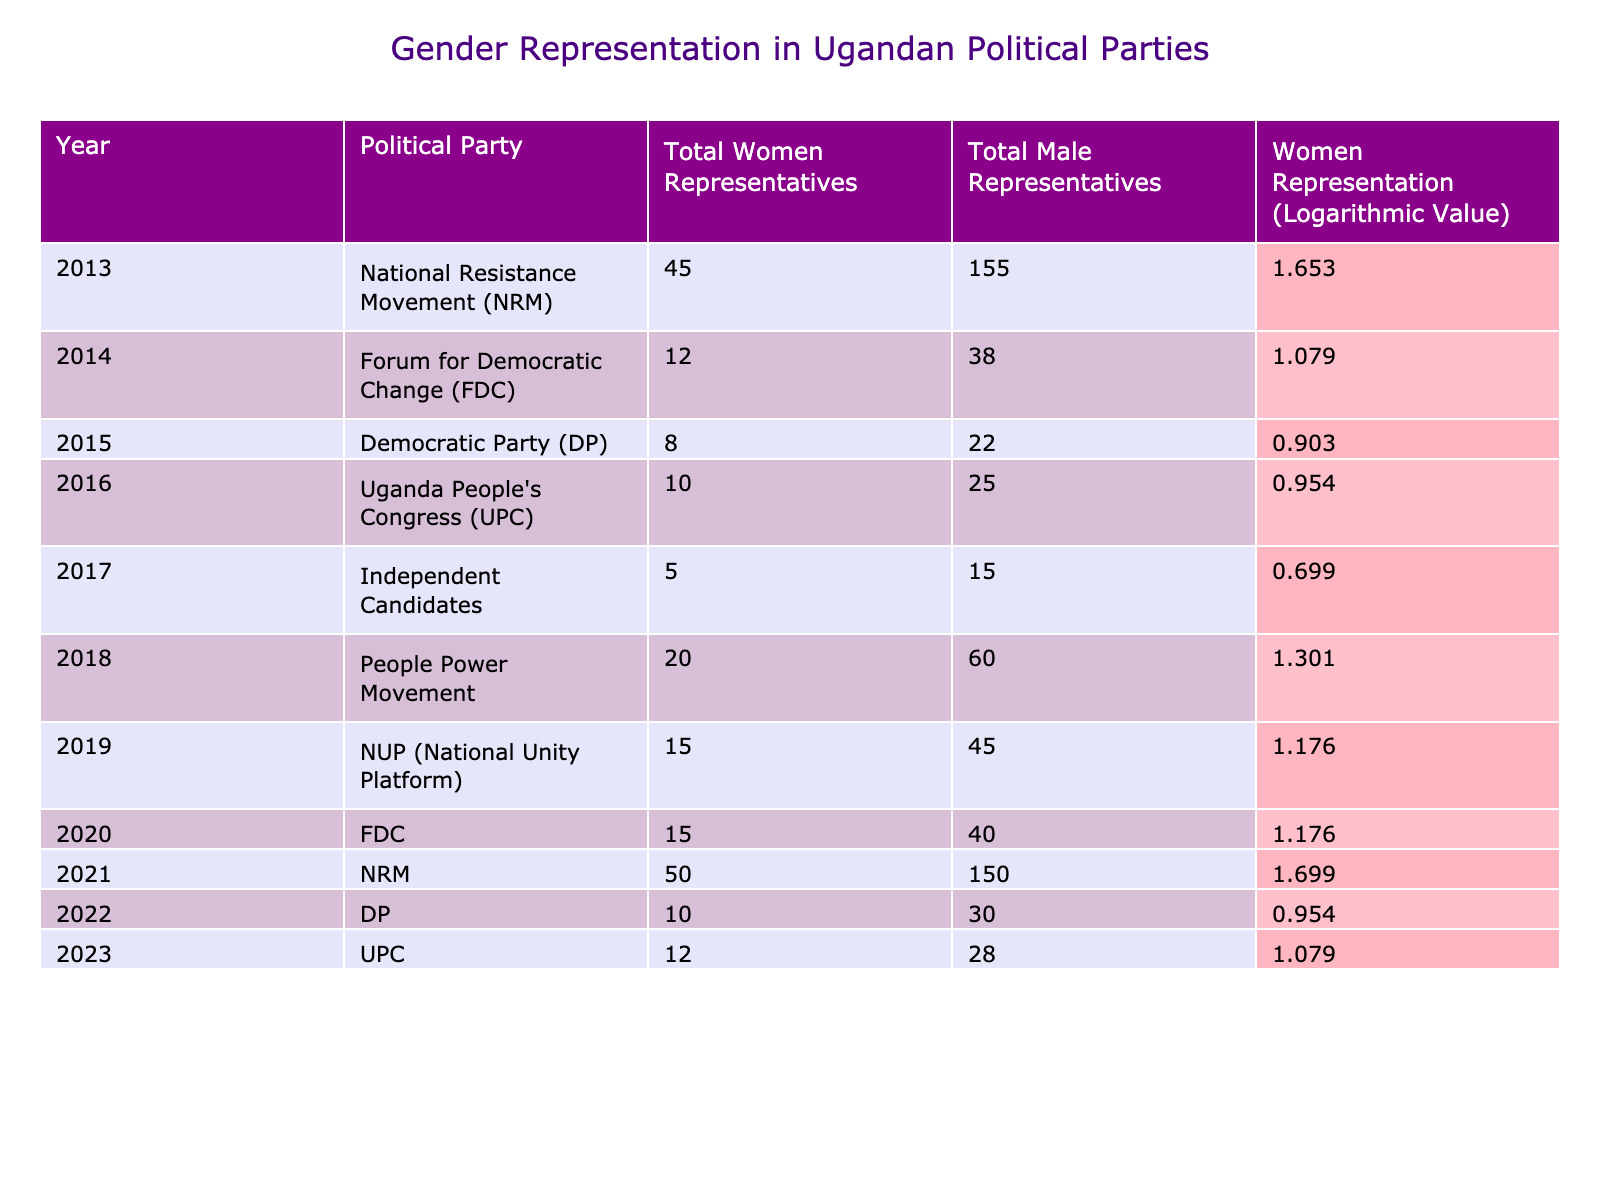What was the total number of women representatives for the NRM in 2021? By looking at the table, the row for the NRM in 2021 shows that there were 50 total women representatives.
Answer: 50 Which party had the lowest number of women representatives in 2015? The Democratic Party (DP) listed 8 total women representatives in 2015, which is the lowest compared to the other parties in that year.
Answer: 8 What is the logarithmic value of women representation for the Forum for Democratic Change in 2020? The table shows that for the Forum for Democratic Change in 2020, the logarithmic value of women representation is 1.176.
Answer: 1.176 In which year did Independent Candidates show the lowest women's representation? In 2017, Independent Candidates had 5 women representatives, which is the lowest in the table across all listed years.
Answer: 2017 What was the average logarithmic value of women representation for NRM from 2013 to 2021? The logarithmic values for NRM from 2013 (1.653), 2021 (1.699) are summed up: 1.653 + 1.699 = 3.352. Since there are 2 data points, the average is 3.352/2 = 1.676.
Answer: 1.676 Did the number of women representatives for DP increase from 2015 to 2022? The data shows that in 2015 there were 8 women representatives and in 2022 there were 10. Since 10 is greater than 8, the number did increase.
Answer: Yes Which political party had the highest total of male representatives in 2013? According to the table, the NRM had the highest total of male representatives in 2013, with 155 males.
Answer: 155 How many more total women representatives did the NRM have than the UPC in 2023? The NRM is not listed for 2023, but the UPC had 12 women representatives in that year. Since there is no data for NRM in 2023, we cannot calculate a difference. Thus, the answer is not applicable.
Answer: Not applicable What is the trend for total women representatives in the Forum for Democratic Change from 2014 to 2020? The total women representatives for FDC were 12 in 2014, increased to 15 in 2020. Therefore, the trend shows an increase over these years.
Answer: Increase Was there ever a year when women represented more than 1.5% in the Democratic Party? The table shows that the maximum women representation for the Democratic Party is 10 women representatives in 2022, which corresponds to a logarithmic value less than 1.5; therefore, the answer is no.
Answer: No 